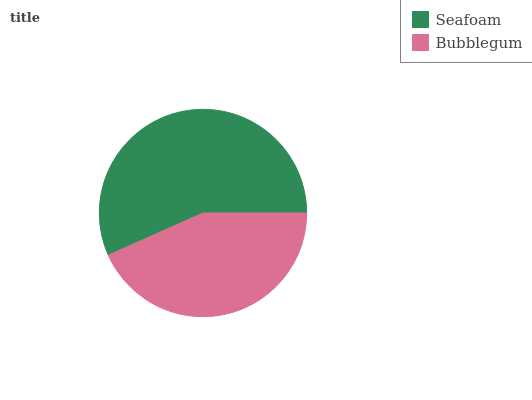Is Bubblegum the minimum?
Answer yes or no. Yes. Is Seafoam the maximum?
Answer yes or no. Yes. Is Bubblegum the maximum?
Answer yes or no. No. Is Seafoam greater than Bubblegum?
Answer yes or no. Yes. Is Bubblegum less than Seafoam?
Answer yes or no. Yes. Is Bubblegum greater than Seafoam?
Answer yes or no. No. Is Seafoam less than Bubblegum?
Answer yes or no. No. Is Seafoam the high median?
Answer yes or no. Yes. Is Bubblegum the low median?
Answer yes or no. Yes. Is Bubblegum the high median?
Answer yes or no. No. Is Seafoam the low median?
Answer yes or no. No. 